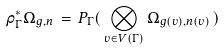<formula> <loc_0><loc_0><loc_500><loc_500>\rho _ { \Gamma } ^ { * } \Omega _ { g , n } \, = \, P _ { \Gamma } ( \, \bigotimes _ { v \in V ( \Gamma ) } \Omega _ { g ( v ) , n ( v ) } \, )</formula> 